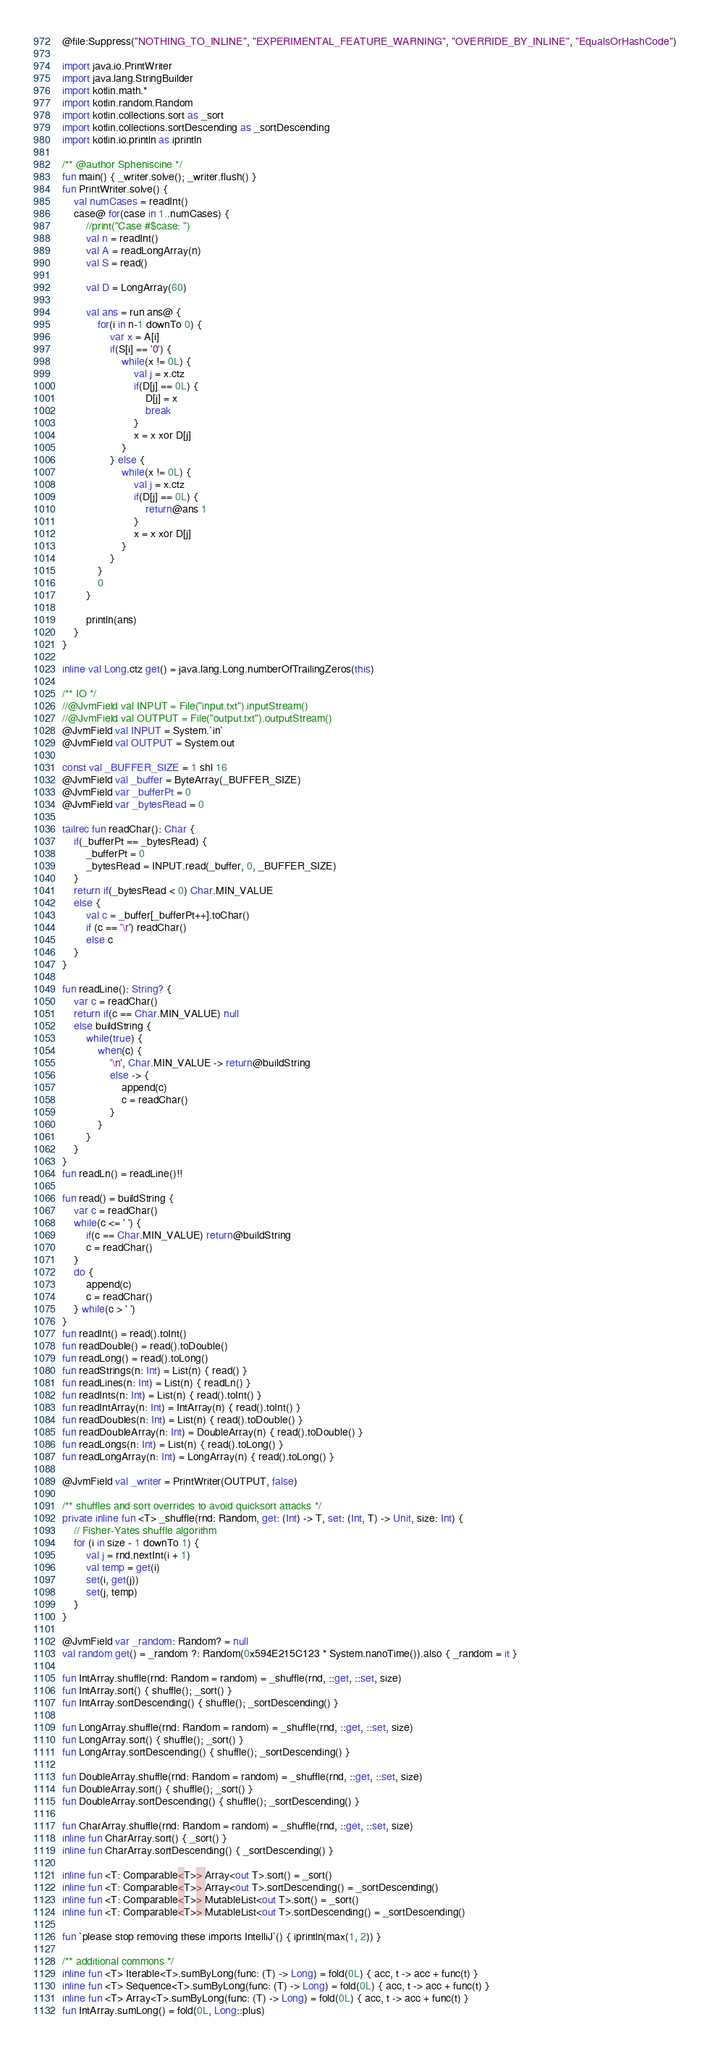<code> <loc_0><loc_0><loc_500><loc_500><_Kotlin_>@file:Suppress("NOTHING_TO_INLINE", "EXPERIMENTAL_FEATURE_WARNING", "OVERRIDE_BY_INLINE", "EqualsOrHashCode")

import java.io.PrintWriter
import java.lang.StringBuilder
import kotlin.math.*
import kotlin.random.Random
import kotlin.collections.sort as _sort
import kotlin.collections.sortDescending as _sortDescending
import kotlin.io.println as iprintln

/** @author Spheniscine */
fun main() { _writer.solve(); _writer.flush() }
fun PrintWriter.solve() {
    val numCases = readInt()
    case@ for(case in 1..numCases) {
        //print("Case #$case: ")
        val n = readInt()
        val A = readLongArray(n)
        val S = read()

        val D = LongArray(60)

        val ans = run ans@ {
            for(i in n-1 downTo 0) {
                var x = A[i]
                if(S[i] == '0') {
                    while(x != 0L) {
                        val j = x.ctz
                        if(D[j] == 0L) {
                            D[j] = x
                            break
                        }
                        x = x xor D[j]
                    }
                } else {
                    while(x != 0L) {
                        val j = x.ctz
                        if(D[j] == 0L) {
                            return@ans 1
                        }
                        x = x xor D[j]
                    }
                }
            }
            0
        }

        println(ans)
    }
}

inline val Long.ctz get() = java.lang.Long.numberOfTrailingZeros(this)

/** IO */
//@JvmField val INPUT = File("input.txt").inputStream()
//@JvmField val OUTPUT = File("output.txt").outputStream()
@JvmField val INPUT = System.`in`
@JvmField val OUTPUT = System.out

const val _BUFFER_SIZE = 1 shl 16
@JvmField val _buffer = ByteArray(_BUFFER_SIZE)
@JvmField var _bufferPt = 0
@JvmField var _bytesRead = 0

tailrec fun readChar(): Char {
    if(_bufferPt == _bytesRead) {
        _bufferPt = 0
        _bytesRead = INPUT.read(_buffer, 0, _BUFFER_SIZE)
    }
    return if(_bytesRead < 0) Char.MIN_VALUE
    else {
        val c = _buffer[_bufferPt++].toChar()
        if (c == '\r') readChar()
        else c
    }
}

fun readLine(): String? {
    var c = readChar()
    return if(c == Char.MIN_VALUE) null
    else buildString {
        while(true) {
            when(c) {
                '\n', Char.MIN_VALUE -> return@buildString
                else -> {
                    append(c)
                    c = readChar()
                }
            }
        }
    }
}
fun readLn() = readLine()!!

fun read() = buildString {
    var c = readChar()
    while(c <= ' ') {
        if(c == Char.MIN_VALUE) return@buildString
        c = readChar()
    }
    do {
        append(c)
        c = readChar()
    } while(c > ' ')
}
fun readInt() = read().toInt()
fun readDouble() = read().toDouble()
fun readLong() = read().toLong()
fun readStrings(n: Int) = List(n) { read() }
fun readLines(n: Int) = List(n) { readLn() }
fun readInts(n: Int) = List(n) { read().toInt() }
fun readIntArray(n: Int) = IntArray(n) { read().toInt() }
fun readDoubles(n: Int) = List(n) { read().toDouble() }
fun readDoubleArray(n: Int) = DoubleArray(n) { read().toDouble() }
fun readLongs(n: Int) = List(n) { read().toLong() }
fun readLongArray(n: Int) = LongArray(n) { read().toLong() }

@JvmField val _writer = PrintWriter(OUTPUT, false)

/** shuffles and sort overrides to avoid quicksort attacks */
private inline fun <T> _shuffle(rnd: Random, get: (Int) -> T, set: (Int, T) -> Unit, size: Int) {
    // Fisher-Yates shuffle algorithm
    for (i in size - 1 downTo 1) {
        val j = rnd.nextInt(i + 1)
        val temp = get(i)
        set(i, get(j))
        set(j, temp)
    }
}

@JvmField var _random: Random? = null
val random get() = _random ?: Random(0x594E215C123 * System.nanoTime()).also { _random = it }

fun IntArray.shuffle(rnd: Random = random) = _shuffle(rnd, ::get, ::set, size)
fun IntArray.sort() { shuffle(); _sort() }
fun IntArray.sortDescending() { shuffle(); _sortDescending() }

fun LongArray.shuffle(rnd: Random = random) = _shuffle(rnd, ::get, ::set, size)
fun LongArray.sort() { shuffle(); _sort() }
fun LongArray.sortDescending() { shuffle(); _sortDescending() }

fun DoubleArray.shuffle(rnd: Random = random) = _shuffle(rnd, ::get, ::set, size)
fun DoubleArray.sort() { shuffle(); _sort() }
fun DoubleArray.sortDescending() { shuffle(); _sortDescending() }

fun CharArray.shuffle(rnd: Random = random) = _shuffle(rnd, ::get, ::set, size)
inline fun CharArray.sort() { _sort() }
inline fun CharArray.sortDescending() { _sortDescending() }

inline fun <T: Comparable<T>> Array<out T>.sort() = _sort()
inline fun <T: Comparable<T>> Array<out T>.sortDescending() = _sortDescending()
inline fun <T: Comparable<T>> MutableList<out T>.sort() = _sort()
inline fun <T: Comparable<T>> MutableList<out T>.sortDescending() = _sortDescending()

fun `please stop removing these imports IntelliJ`() { iprintln(max(1, 2)) }

/** additional commons */
inline fun <T> Iterable<T>.sumByLong(func: (T) -> Long) = fold(0L) { acc, t -> acc + func(t) }
inline fun <T> Sequence<T>.sumByLong(func: (T) -> Long) = fold(0L) { acc, t -> acc + func(t) }
inline fun <T> Array<T>.sumByLong(func: (T) -> Long) = fold(0L) { acc, t -> acc + func(t) }
fun IntArray.sumLong() = fold(0L, Long::plus)</code> 